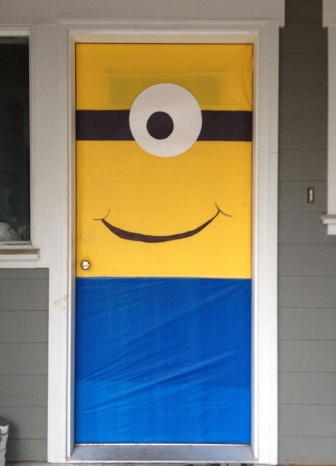What is this photo about? The image showcases a door that has been creatively decorated with a large poster of a minion from the popular animated movie 'Despicable Me'. The door itself is white and stands out against the gray exterior wall of the house. The poster has three distinct horizontal sections: a yellow top section featuring a minion's eye; a black middle section representing the strap of the goggles; and a blue lower section reminiscent of the minion's overalls. To the right of the door, there is a shiny doorknob, and on the left side of the door, a window offers a glimpse into the interior of the house. The minion poster adds a lively and whimsical touch to the otherwise plain setting. 